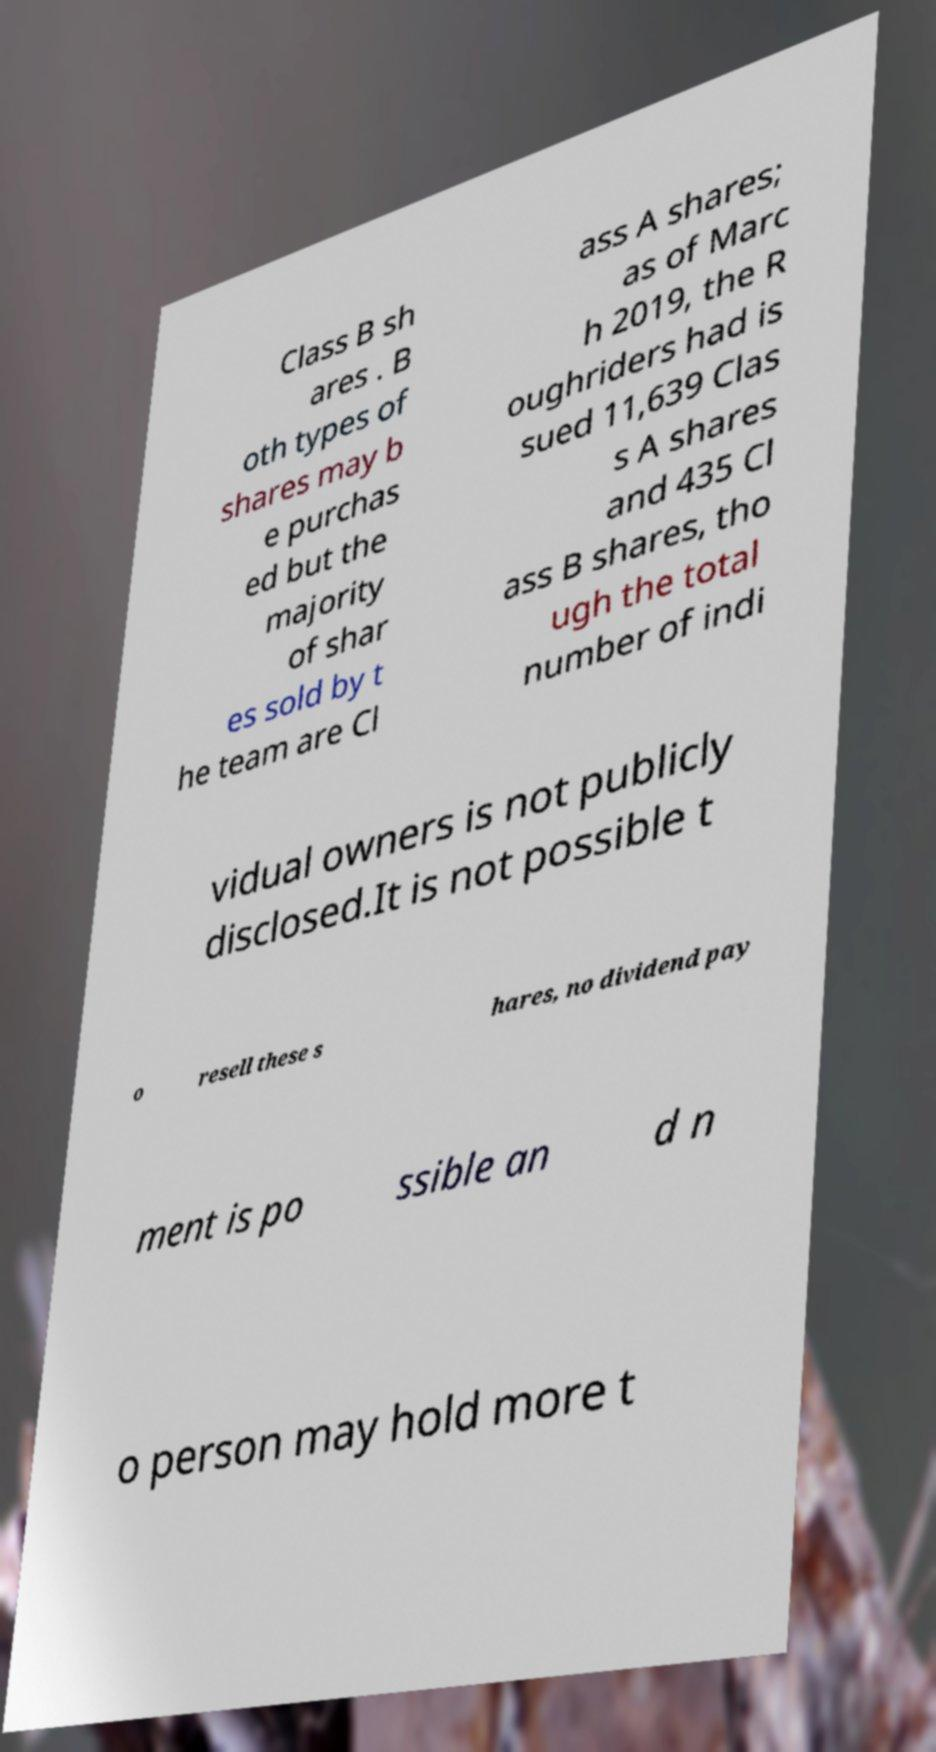I need the written content from this picture converted into text. Can you do that? Class B sh ares . B oth types of shares may b e purchas ed but the majority of shar es sold by t he team are Cl ass A shares; as of Marc h 2019, the R oughriders had is sued 11,639 Clas s A shares and 435 Cl ass B shares, tho ugh the total number of indi vidual owners is not publicly disclosed.It is not possible t o resell these s hares, no dividend pay ment is po ssible an d n o person may hold more t 